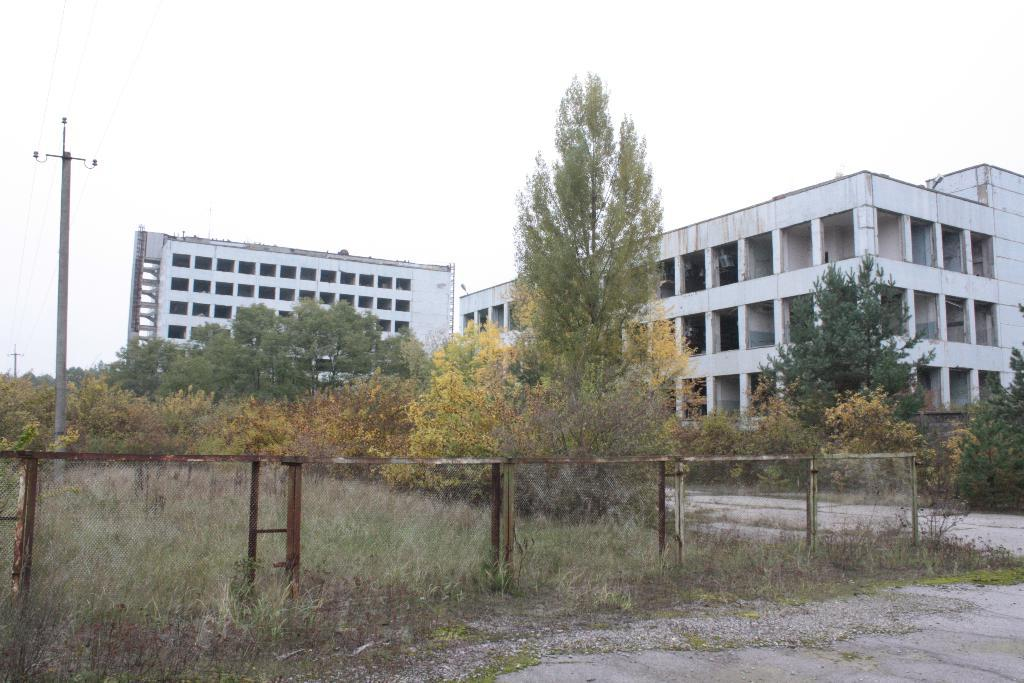What type of vegetation can be seen in the image? There is grass and plants in the image. What structures are present in the image? There is a fence, light poles, wires, trees, buildings, and pillars in the image. What is visible in the background of the image? The sky is visible in the image. Can you describe the time of day when the image was likely taken? The image was likely taken during the day, as there is no indication of darkness or artificial lighting. What shape is the sign that is present in the image? There is no sign present in the image; it only contains grass, plants, a fence, light poles, wires, trees, buildings, pillars, and the sky. 